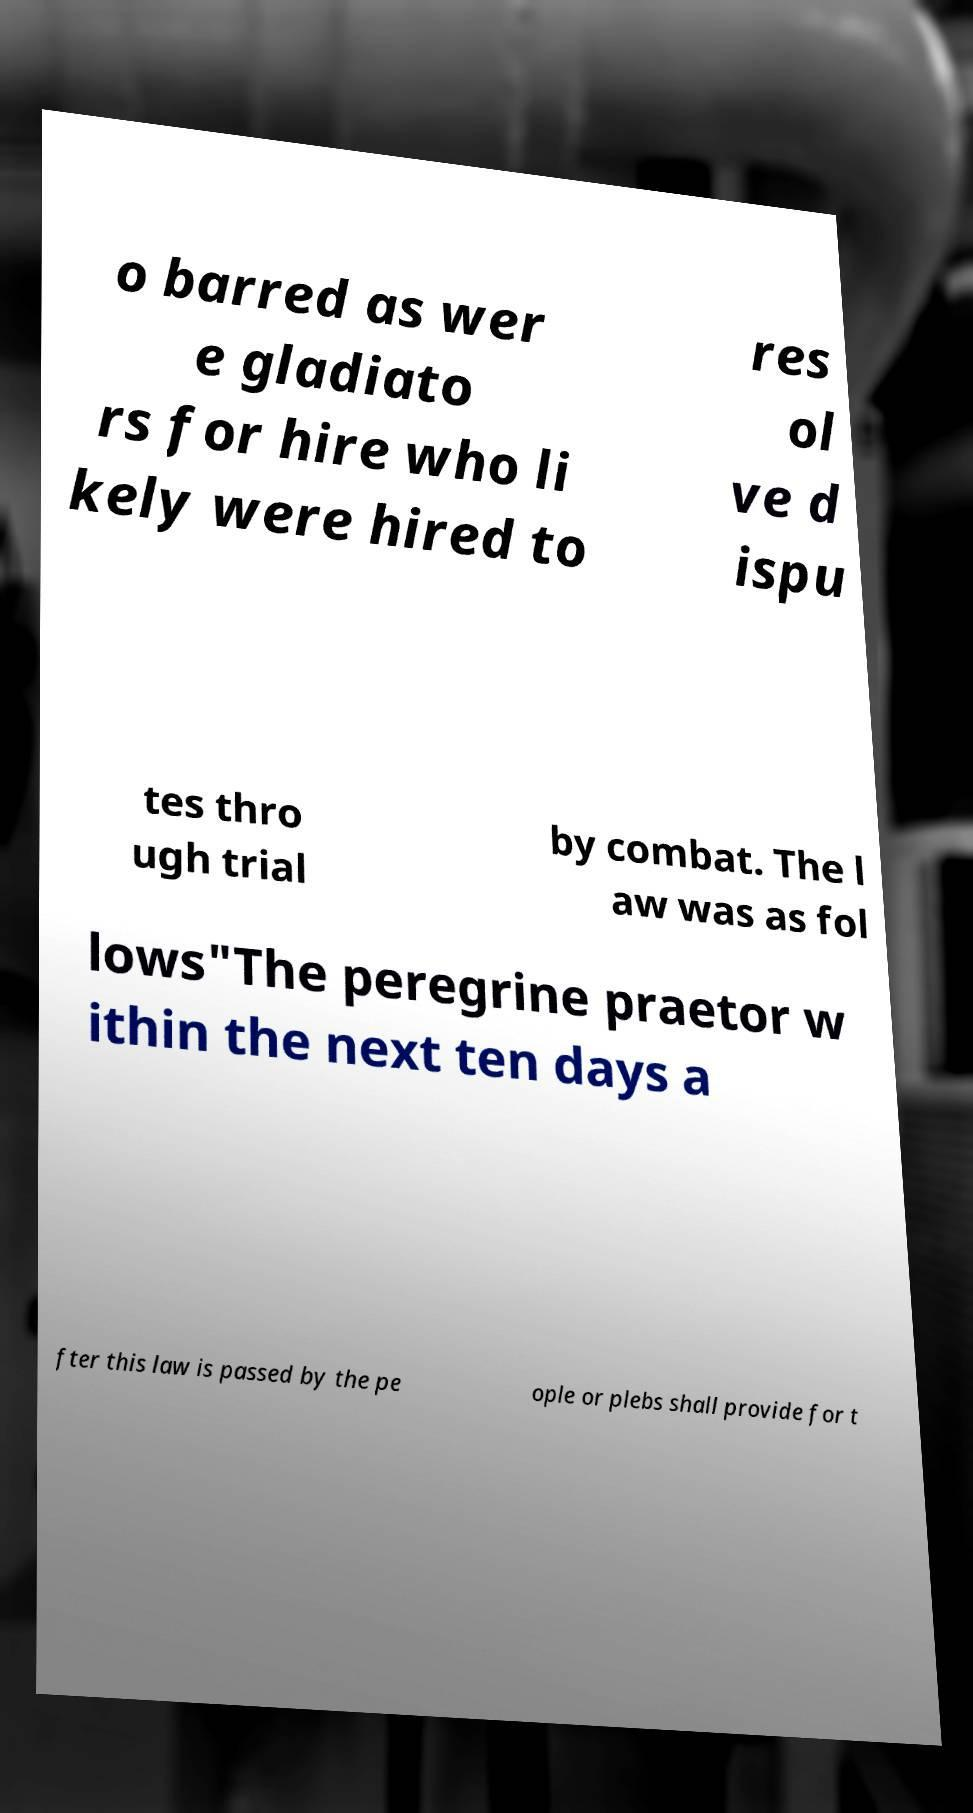Can you read and provide the text displayed in the image?This photo seems to have some interesting text. Can you extract and type it out for me? o barred as wer e gladiato rs for hire who li kely were hired to res ol ve d ispu tes thro ugh trial by combat. The l aw was as fol lows"The peregrine praetor w ithin the next ten days a fter this law is passed by the pe ople or plebs shall provide for t 